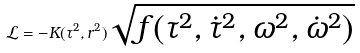Convert formula to latex. <formula><loc_0><loc_0><loc_500><loc_500>\mathcal { L } = - K ( \tau ^ { 2 } , r ^ { 2 } ) \sqrt { f ( \tau ^ { 2 } , \dot { \tau } ^ { 2 } , \omega ^ { 2 } , \dot { \omega } ^ { 2 } ) }</formula> 